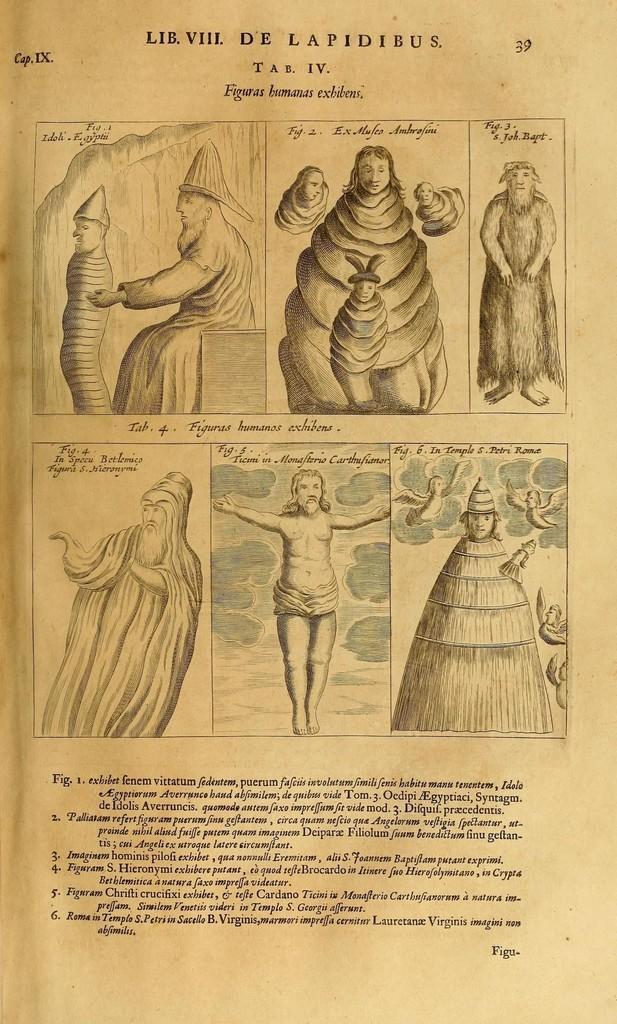How would you summarize this image in a sentence or two? In this image we can see a page of a book were we can see diagrams and some text written on it. 